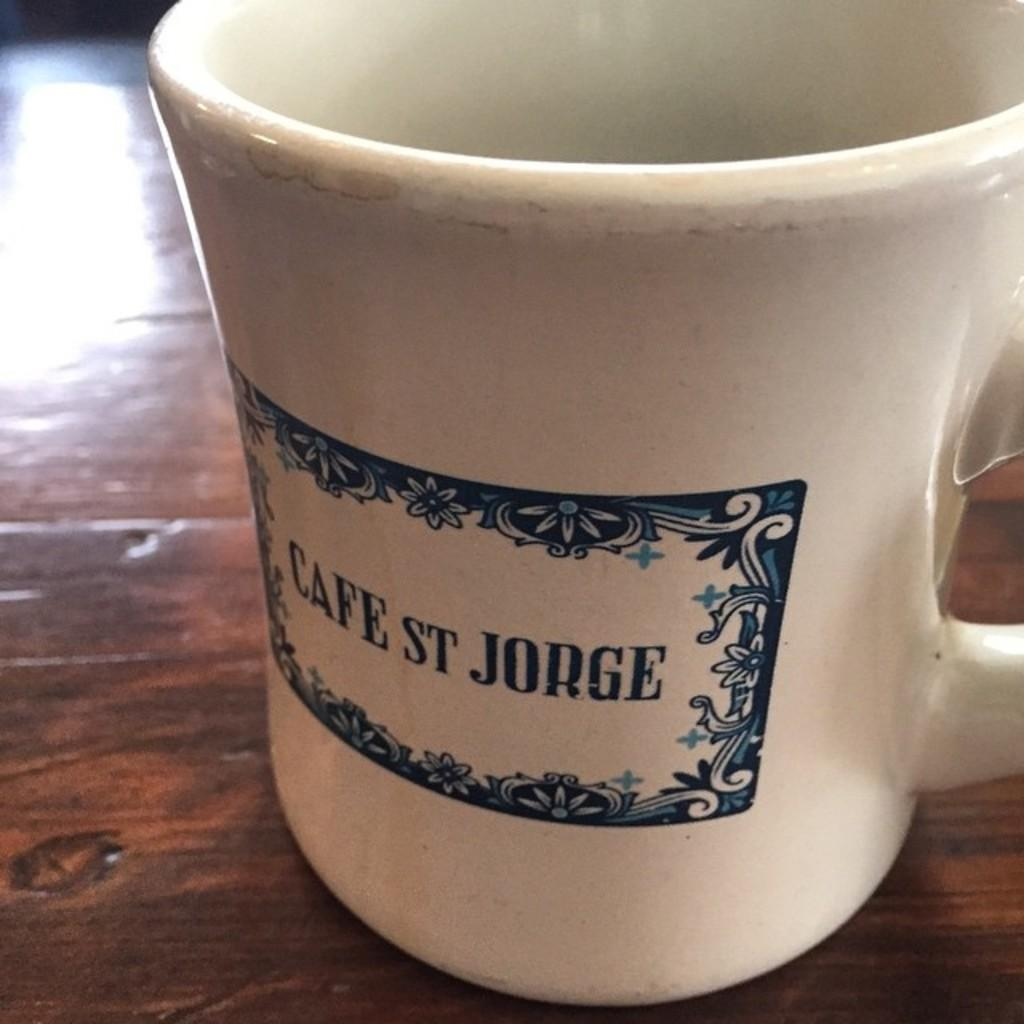<image>
Present a compact description of the photo's key features. a mug with the caption "cafee st jorge" on a wooden table. 